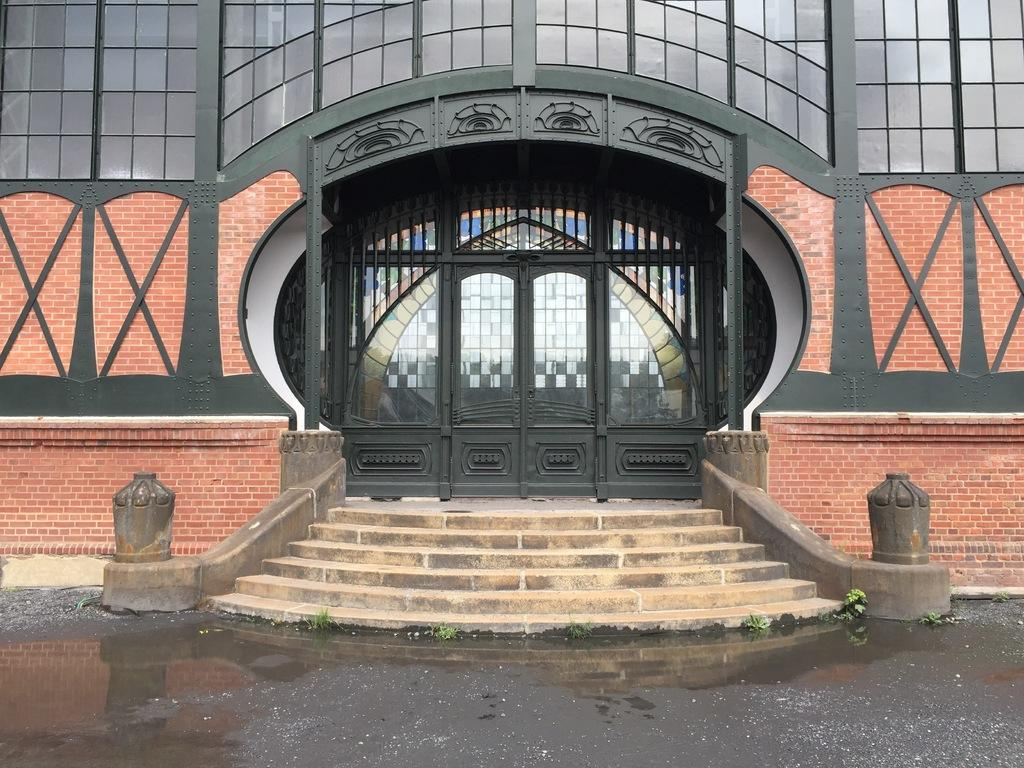What is the main feature of the image? There is a road in the image. What is unusual about the road? Grass is present on the road, and there is water visible on it. What can be seen in the background of the image? There are stairs, a building, and doors in the background of the image. Can you see a farmer tending to a clover field in the image? There is no farmer or clover field present in the image. 